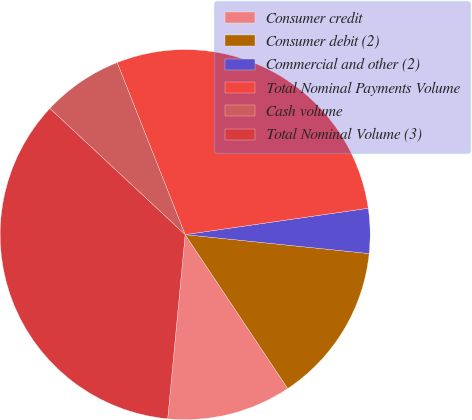Convert chart. <chart><loc_0><loc_0><loc_500><loc_500><pie_chart><fcel>Consumer credit<fcel>Consumer debit (2)<fcel>Commercial and other (2)<fcel>Total Nominal Payments Volume<fcel>Cash volume<fcel>Total Nominal Volume (3)<nl><fcel>10.86%<fcel>14.01%<fcel>3.91%<fcel>28.71%<fcel>7.07%<fcel>35.44%<nl></chart> 